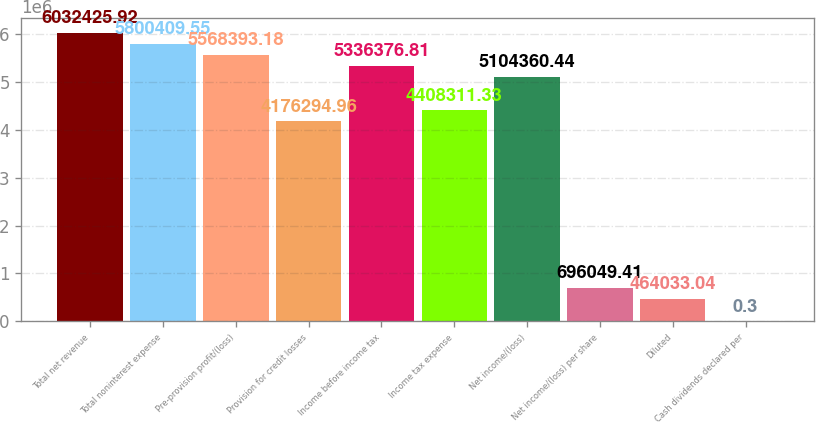<chart> <loc_0><loc_0><loc_500><loc_500><bar_chart><fcel>Total net revenue<fcel>Total noninterest expense<fcel>Pre-provision profit/(loss)<fcel>Provision for credit losses<fcel>Income before income tax<fcel>Income tax expense<fcel>Net income/(loss)<fcel>Net income/(loss) per share<fcel>Diluted<fcel>Cash dividends declared per<nl><fcel>6.03243e+06<fcel>5.80041e+06<fcel>5.56839e+06<fcel>4.17629e+06<fcel>5.33638e+06<fcel>4.40831e+06<fcel>5.10436e+06<fcel>696049<fcel>464033<fcel>0.3<nl></chart> 